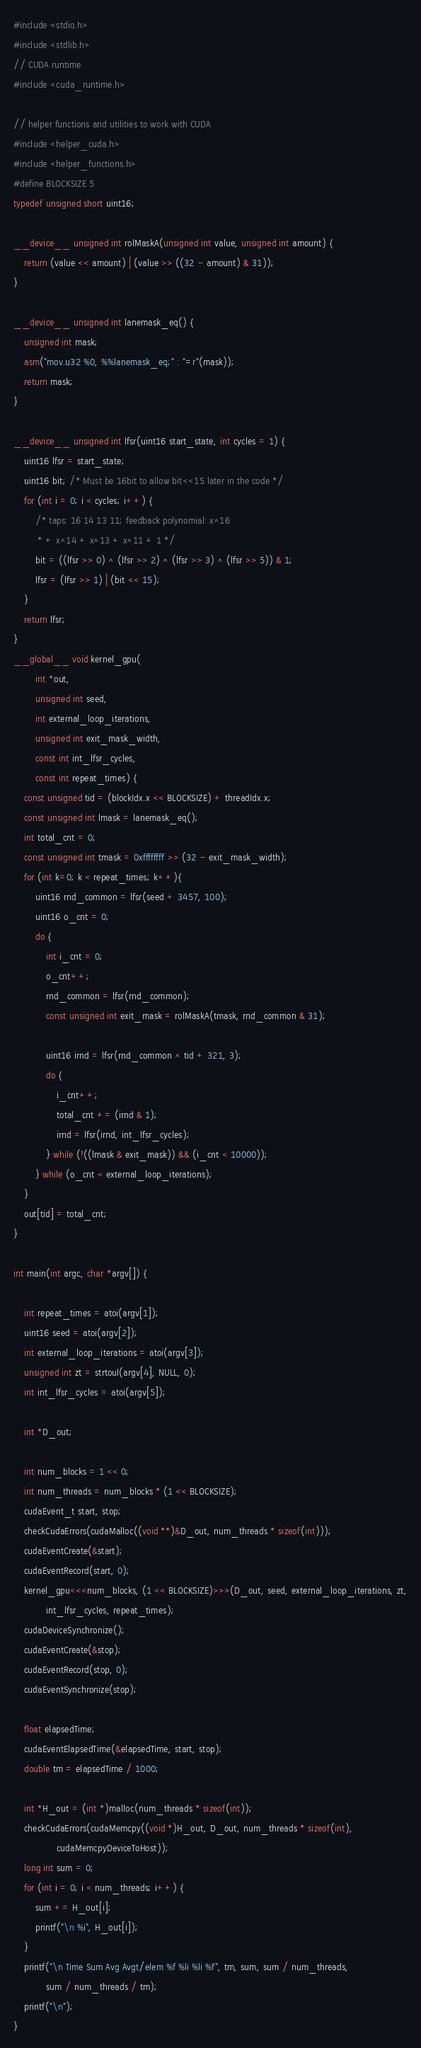Convert code to text. <code><loc_0><loc_0><loc_500><loc_500><_Cuda_>#include <stdio.h>
#include <stdlib.h>
// CUDA runtime
#include <cuda_runtime.h>

// helper functions and utilities to work with CUDA
#include <helper_cuda.h>
#include <helper_functions.h>
#define BLOCKSIZE 5
typedef unsigned short uint16;

__device__ unsigned int rolMaskA(unsigned int value, unsigned int amount) {
    return (value << amount) | (value >> ((32 - amount) & 31));
}

__device__ unsigned int lanemask_eq() {
    unsigned int mask;
    asm("mov.u32 %0, %%lanemask_eq;" : "=r"(mask));
    return mask;
}

__device__ unsigned int lfsr(uint16 start_state, int cycles = 1) {
    uint16 lfsr = start_state;
    uint16 bit; /* Must be 16bit to allow bit<<15 later in the code */
    for (int i = 0; i < cycles; i++) {
        /* taps: 16 14 13 11; feedback polynomial: x^16
         * + x^14 + x^13 + x^11 + 1 */
        bit = ((lfsr >> 0) ^ (lfsr >> 2) ^ (lfsr >> 3) ^ (lfsr >> 5)) & 1;
        lfsr = (lfsr >> 1) | (bit << 15);
    }
    return lfsr;
}
__global__ void kernel_gpu(
        int *out,
        unsigned int seed,
        int external_loop_iterations,
        unsigned int exit_mask_width,
        const int int_lfsr_cycles,
        const int repeat_times) {
    const unsigned tid = (blockIdx.x << BLOCKSIZE) + threadIdx.x;
    const unsigned int lmask = lanemask_eq();
    int total_cnt = 0;
    const unsigned int tmask = 0xffffffff >> (32 - exit_mask_width);
    for (int k=0; k < repeat_times; k++){
        uint16 rnd_common = lfsr(seed + 3457, 100);
        uint16 o_cnt = 0;
        do {
            int i_cnt = 0;
            o_cnt++;
            rnd_common = lfsr(rnd_common);
            const unsigned int exit_mask = rolMaskA(tmask, rnd_common & 31);

            uint16 irnd = lfsr(rnd_common ^ tid + 321, 3);
            do {
                i_cnt++;
                total_cnt += (irnd & 1);
                irnd = lfsr(irnd, int_lfsr_cycles);
            } while (!((lmask & exit_mask)) && (i_cnt < 10000));
        } while (o_cnt < external_loop_iterations);
    }
    out[tid] = total_cnt;
}

int main(int argc, char *argv[]) {

    int repeat_times = atoi(argv[1]);
    uint16 seed = atoi(argv[2]);
    int external_loop_iterations = atoi(argv[3]);
    unsigned int zt = strtoul(argv[4], NULL, 0);
    int int_lfsr_cycles = atoi(argv[5]);

    int *D_out;

    int num_blocks = 1 << 0;
    int num_threads = num_blocks * (1 << BLOCKSIZE);
    cudaEvent_t start, stop;
    checkCudaErrors(cudaMalloc((void **)&D_out, num_threads * sizeof(int)));
    cudaEventCreate(&start);
    cudaEventRecord(start, 0);
    kernel_gpu<<<num_blocks, (1 << BLOCKSIZE)>>>(D_out, seed, external_loop_iterations, zt,
            int_lfsr_cycles, repeat_times);
    cudaDeviceSynchronize();
    cudaEventCreate(&stop);
    cudaEventRecord(stop, 0);
    cudaEventSynchronize(stop);

    float elapsedTime;
    cudaEventElapsedTime(&elapsedTime, start, stop);
    double tm = elapsedTime / 1000;

    int *H_out = (int *)malloc(num_threads * sizeof(int));
    checkCudaErrors(cudaMemcpy((void *)H_out, D_out, num_threads * sizeof(int),
                cudaMemcpyDeviceToHost));
    long int sum = 0;
    for (int i = 0; i < num_threads; i++) {
        sum += H_out[i];
        printf("\n %i", H_out[i]);
    }
    printf("\n Time Sum Avg Avgt/elem %f %li %li %f", tm, sum, sum / num_threads,
            sum / num_threads / tm);
    printf("\n");
}
</code> 